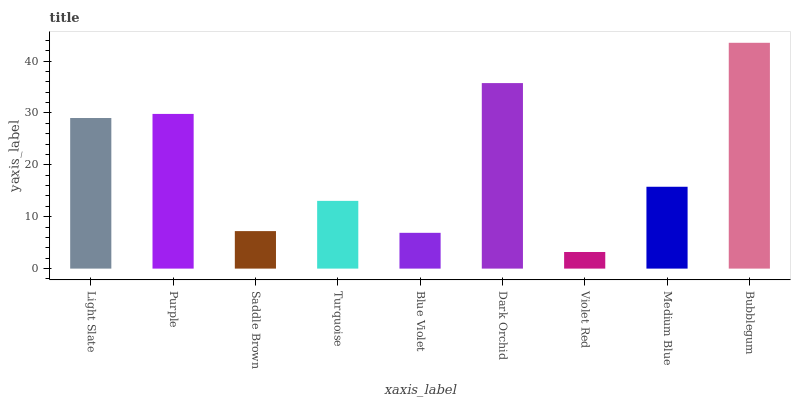Is Violet Red the minimum?
Answer yes or no. Yes. Is Bubblegum the maximum?
Answer yes or no. Yes. Is Purple the minimum?
Answer yes or no. No. Is Purple the maximum?
Answer yes or no. No. Is Purple greater than Light Slate?
Answer yes or no. Yes. Is Light Slate less than Purple?
Answer yes or no. Yes. Is Light Slate greater than Purple?
Answer yes or no. No. Is Purple less than Light Slate?
Answer yes or no. No. Is Medium Blue the high median?
Answer yes or no. Yes. Is Medium Blue the low median?
Answer yes or no. Yes. Is Purple the high median?
Answer yes or no. No. Is Saddle Brown the low median?
Answer yes or no. No. 